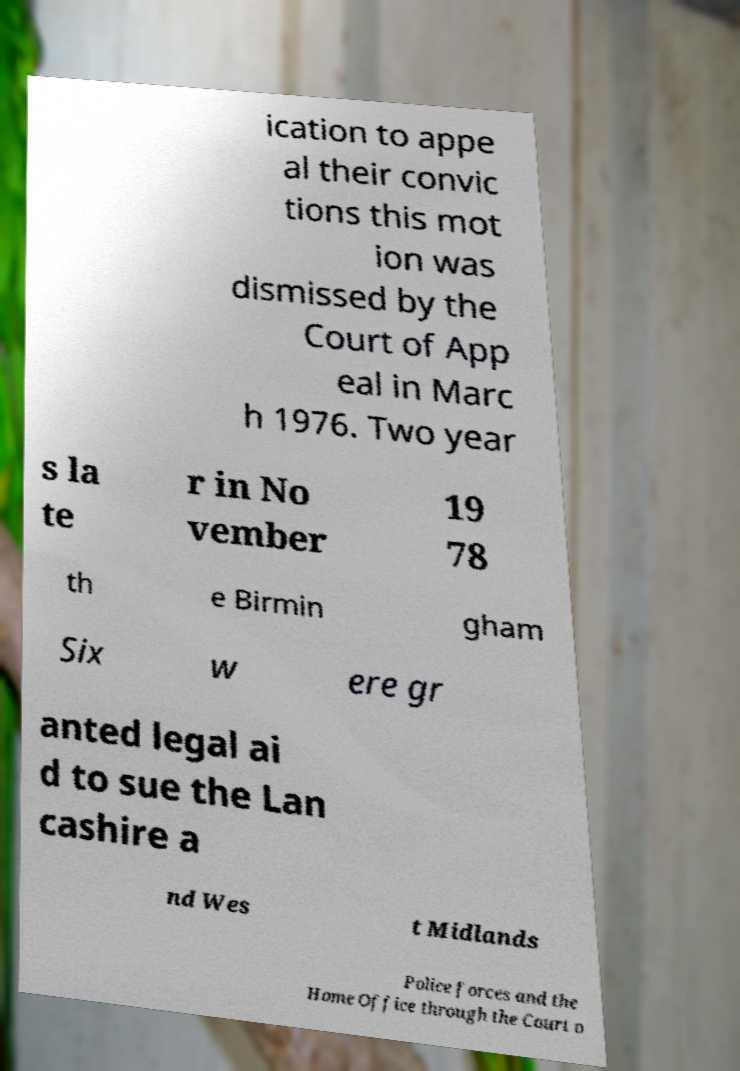What messages or text are displayed in this image? I need them in a readable, typed format. ication to appe al their convic tions this mot ion was dismissed by the Court of App eal in Marc h 1976. Two year s la te r in No vember 19 78 th e Birmin gham Six w ere gr anted legal ai d to sue the Lan cashire a nd Wes t Midlands Police forces and the Home Office through the Court o 